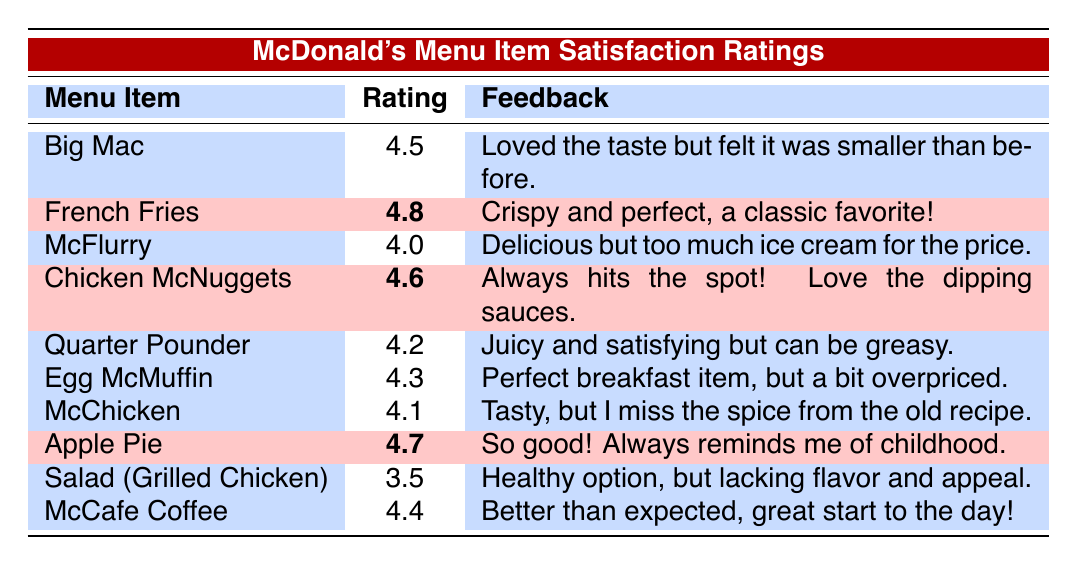What is the satisfaction rating for the French Fries? The table shows that the French Fries have a satisfaction rating of 4.8, highlighted for being a top item.
Answer: 4.8 Which menu item has the lowest satisfaction rating? From the table, the Salad (Grilled Chicken) has the lowest satisfaction rating of 3.5.
Answer: Salad (Grilled Chicken) How many menu items have a satisfaction rating of 4.5 or higher? There are 6 menu items with ratings of 4.5 or higher: Big Mac (4.5), French Fries (4.8), Chicken McNuggets (4.6), Apple Pie (4.7), Quarter Pounder (4.2), and McCafe Coffee (4.4).
Answer: 6 Is the satisfaction rating of McChicken higher than that of Egg McMuffin? The McChicken has a rating of 4.1, while the Egg McMuffin has a rating of 4.3, so the statement is false.
Answer: No Which highlighted menu item has the highest satisfaction rating? The highlighted menu items are French Fries (4.8), Chicken McNuggets (4.6), and Apple Pie (4.7). The highest among these is French Fries at 4.8.
Answer: French Fries What is the average satisfaction rating of all the menu items listed? The ratings are: 4.5, 4.8, 4.0, 4.6, 4.2, 4.3, 4.1, 4.7, 3.5, and 4.4. Calculating the sum gives 46.7, and there are 10 items, so 46.7 ÷ 10 = 4.67.
Answer: 4.67 Which menu item has feedback that suggests the portion size has changed? The feedback for the Big Mac mentions that it was loved but felt smaller than before, indicating a change in portion size.
Answer: Big Mac How do the satisfaction ratings of the highlighted items compare to the average rating of all menu items? The average rating is 4.67. The highlighted items are French Fries (4.8), Chicken McNuggets (4.6), and Apple Pie (4.7), all above the average rating.
Answer: All highlighted items are above average 